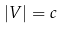Convert formula to latex. <formula><loc_0><loc_0><loc_500><loc_500>| { V } | = c</formula> 